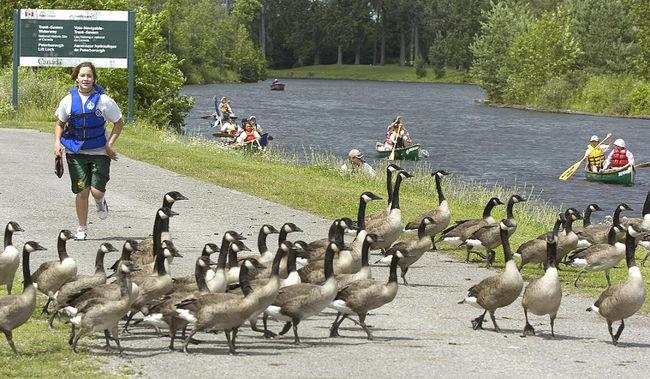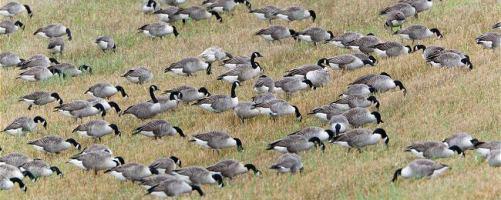The first image is the image on the left, the second image is the image on the right. For the images displayed, is the sentence "There are exactly four people in the image on the left." factually correct? Answer yes or no. No. 